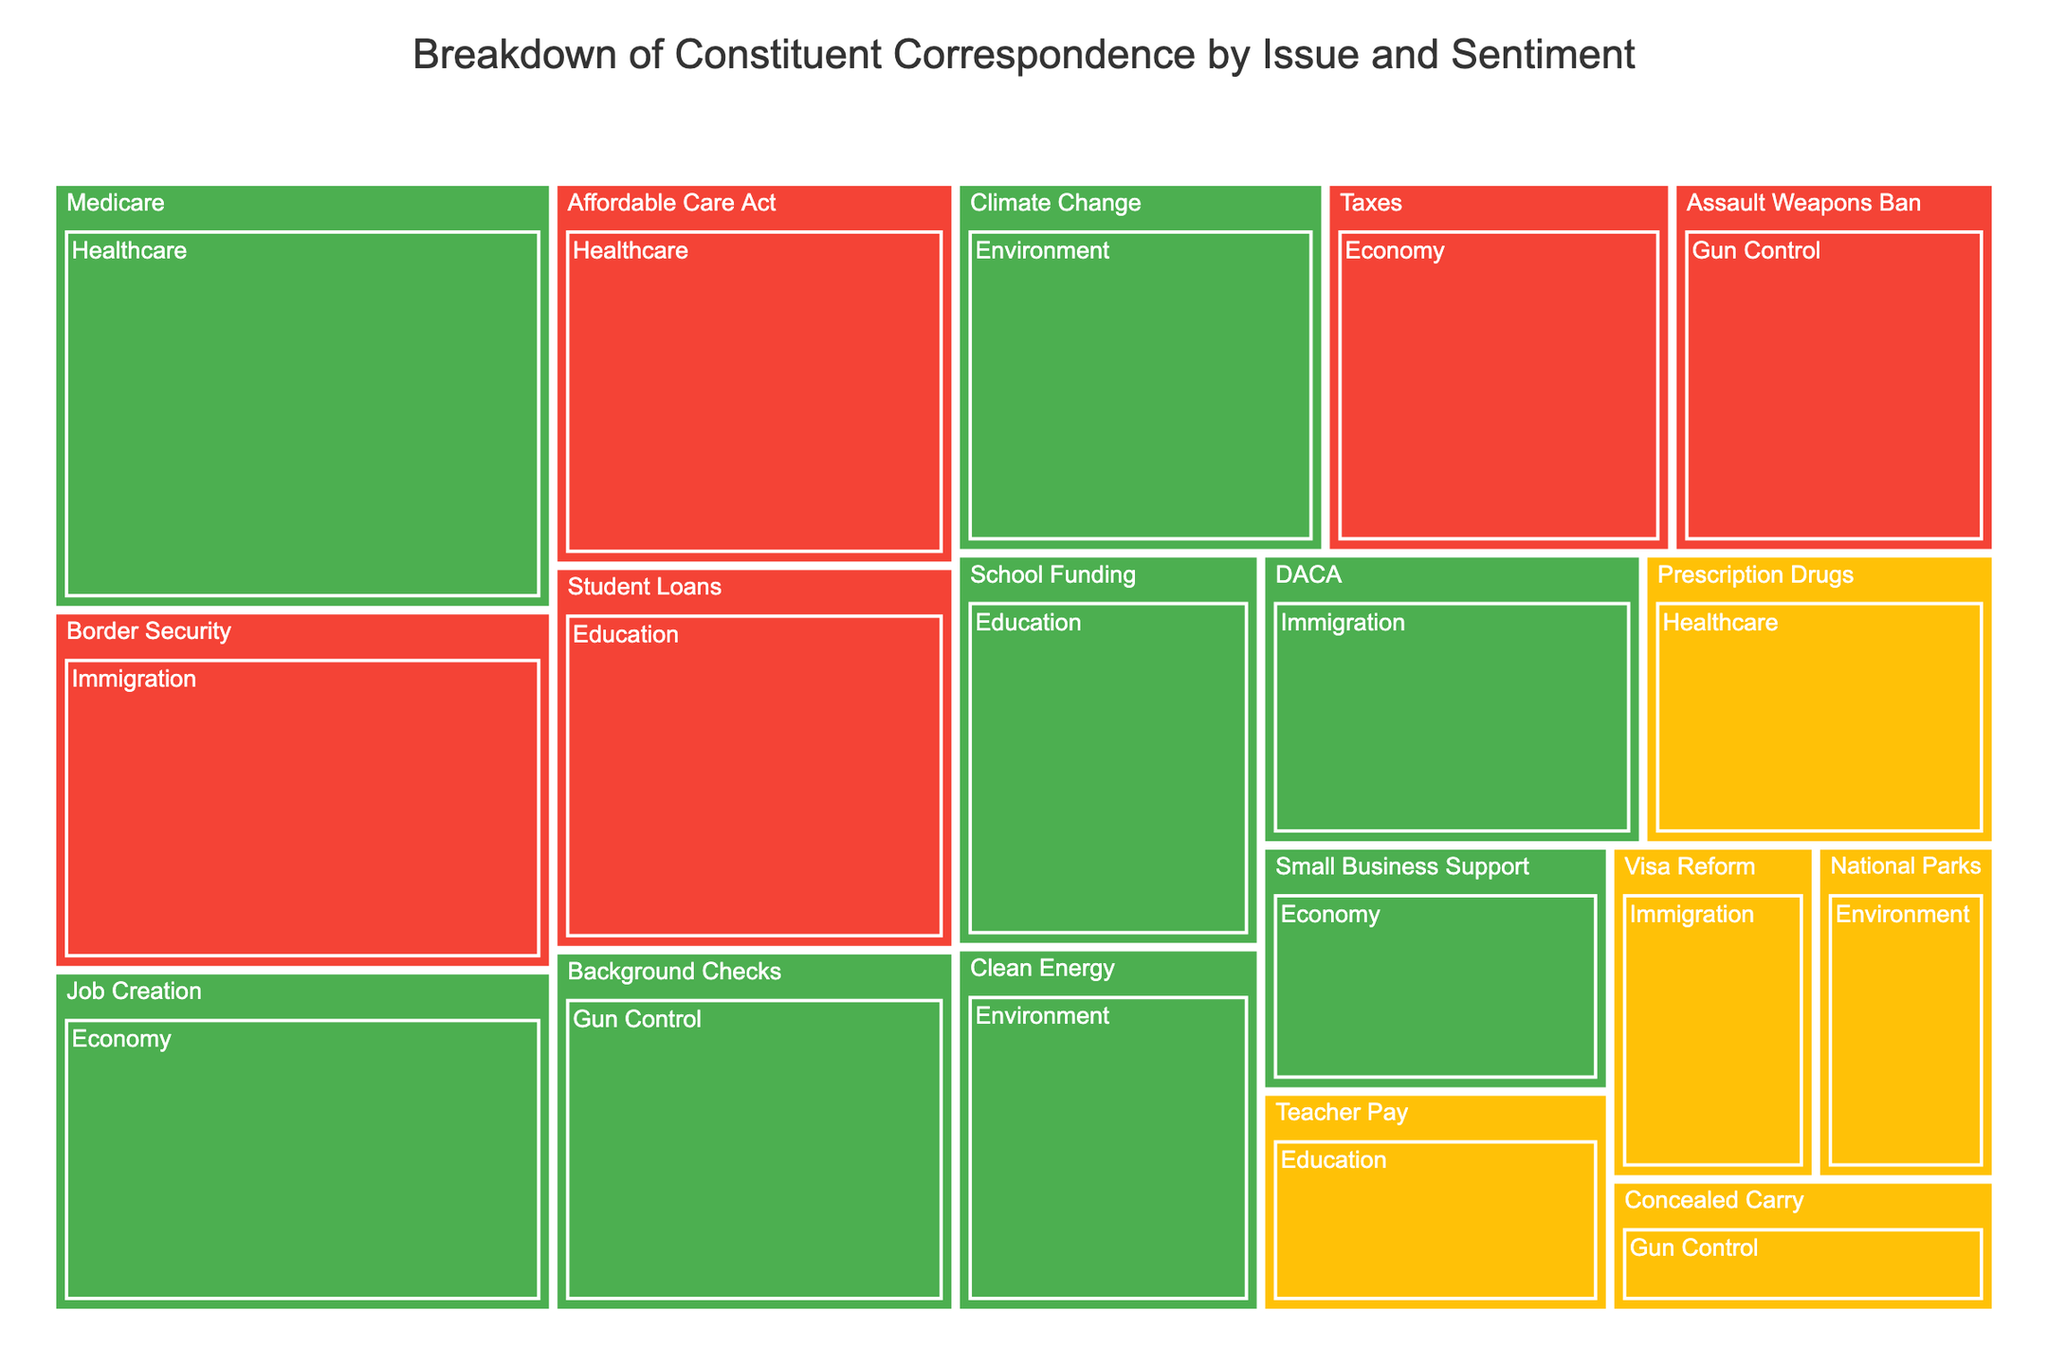What is the title of the treemap? The title is usually displayed prominently at the top of the figure. In this case, the title given in the code is 'Breakdown of Constituent Correspondence by Issue and Sentiment'.
Answer: Breakdown of Constituent Correspondence by Issue and Sentiment Which issue has the highest positive correspondence? By observing the size of the segments and their color, which is green for positive sentiment, we can see that 'Medicare' in the 'Healthcare' issue has the highest positive value.
Answer: Medicare How many issues fall under the Economy category? Each issue is a distinct segment within the Economy category on the treemap. By identifying the segments, we can count three issues: Job Creation, Taxes, and Small Business Support.
Answer: 3 What is the total number of positive correspondences for the Environment issue? To find this, we add the values of positive sentiments under Environment: Climate Change (160) and Clean Energy (130). So, the total is 160 + 130.
Answer: 290 Compare the value of negative correspondences between the Affordable Care Act and Assault Weapons Ban. Which one is higher? By looking at the size and color (red) of the segments, we compare their values: Affordable Care Act (180) vs. Assault Weapons Ban (140). The Affordable Care Act has a higher value.
Answer: Affordable Care Act Which category includes the issue 'Border Security' and what is its sentiment and value? The treemap shows that 'Border Security' falls under the 'Immigration' category. Its color indicates a negative sentiment, and its value is 210.
Answer: Immigration, Negative, 210 What is the value of neutral correspondences for Prescription Drugs and Teacher Pay? By examining the segments for these issues under their respective categories, we find Prescription Drugs has a value of 120 and Teacher Pay has 90. Their combined value is 120 + 90.
Answer: 210 Which issue under Education has the least correspondence, and what is its value? Under the Education category, by comparing the sizes of segments, 'Teacher Pay' has the smallest segment with a value of 90.
Answer: Teacher Pay, 90 Which category shows the most diverse sentiments (all three: Positive, Neutral, Negative)? By analyzing the color range (green, yellow, red) within each category, Education includes all three sentiments: Positive (School Funding), Neutral (Teacher Pay), and Negative (Student Loans).
Answer: Education Does Healthcare have any neutral correspondences, and if so, which issue and what value? The treemap shows neutral correspondences in yellow. Under Healthcare, Prescription Drugs has a neutral sentiment with a value of 120.
Answer: Prescription Drugs, 120 